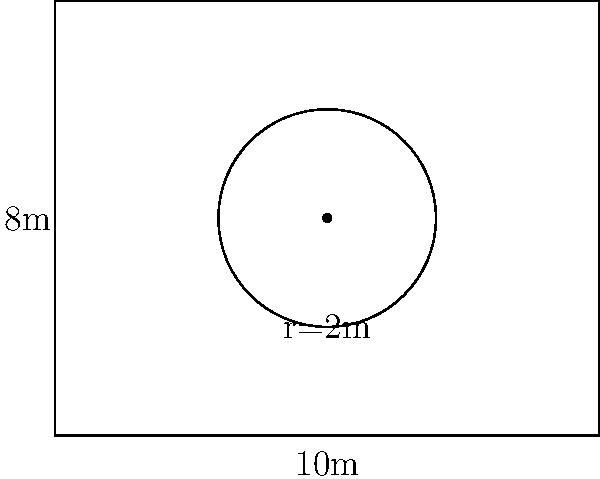A mosque's prayer hall consists of a rectangular area with a circular mihrab niche. The rectangular area measures 10m by 8m, and the circular mihrab has a radius of 2m. What is the total area of the prayer hall, including the mihrab? To calculate the total area of the prayer hall, we need to follow these steps:

1. Calculate the area of the rectangle:
   $A_{rectangle} = length \times width$
   $A_{rectangle} = 10m \times 8m = 80m^2$

2. Calculate the area of the circle (mihrab):
   $A_{circle} = \pi r^2$
   $A_{circle} = \pi \times (2m)^2 = 4\pi m^2$

3. Add the two areas together to get the total area:
   $A_{total} = A_{rectangle} + A_{circle}$
   $A_{total} = 80m^2 + 4\pi m^2$

4. Simplify the expression:
   $A_{total} = 80 + 4\pi m^2$
   $A_{total} \approx 92.57 m^2$ (rounded to two decimal places)

The total area of the prayer hall, including the mihrab, is approximately 92.57 square meters.
Answer: $80 + 4\pi m^2$ or approximately $92.57 m^2$ 